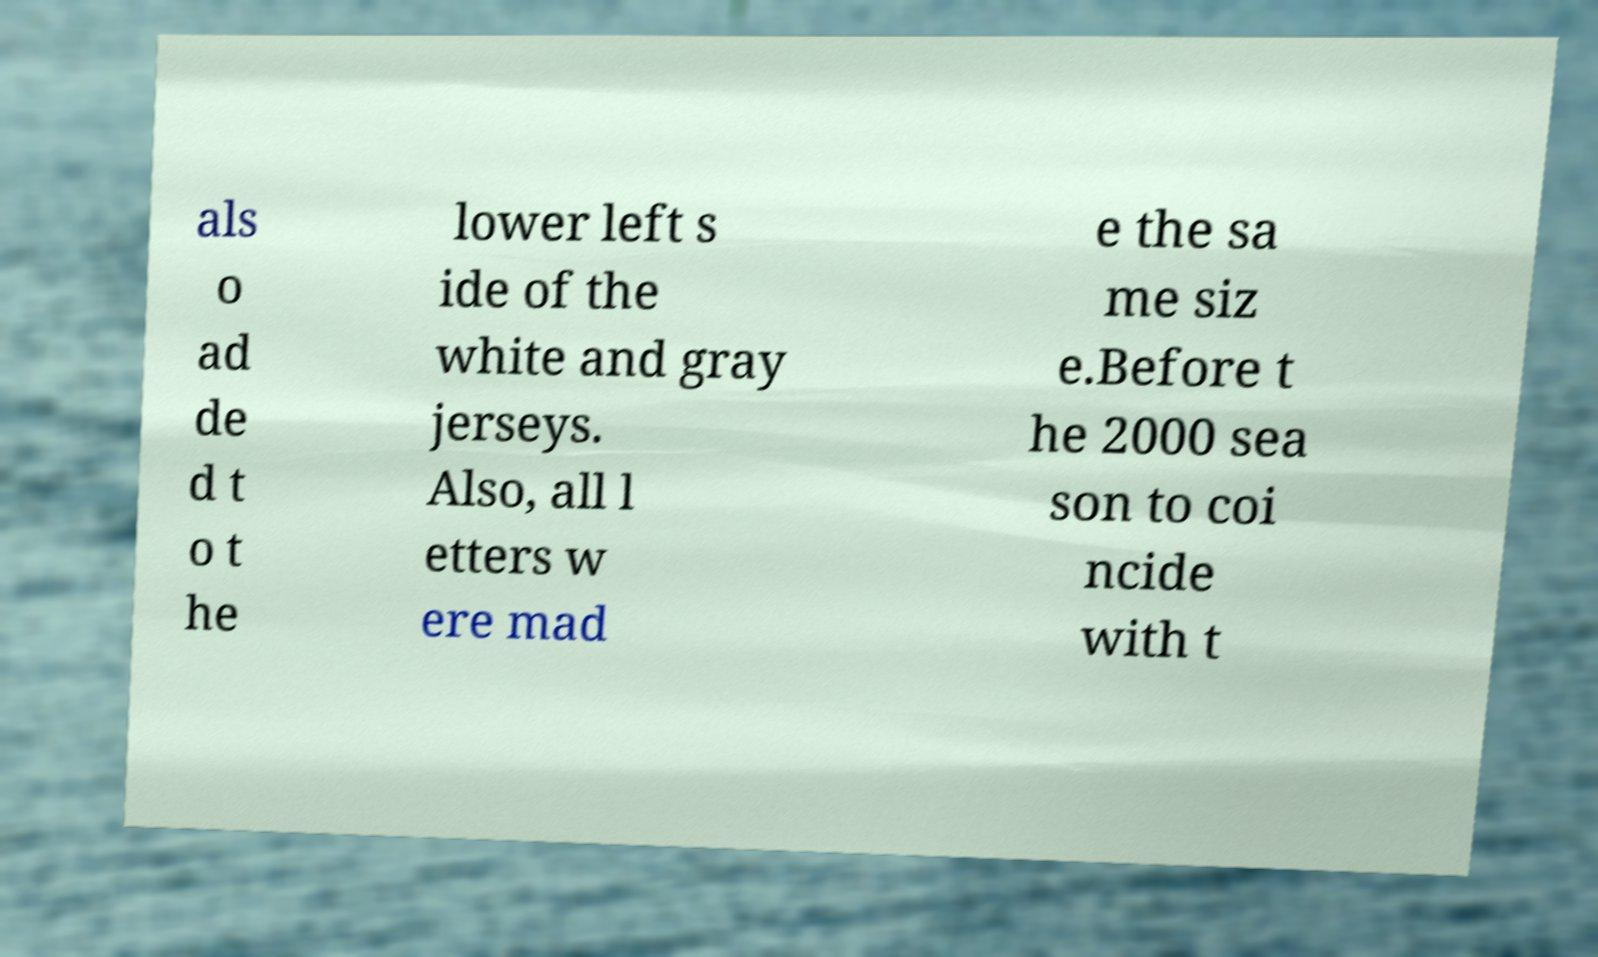Could you extract and type out the text from this image? als o ad de d t o t he lower left s ide of the white and gray jerseys. Also, all l etters w ere mad e the sa me siz e.Before t he 2000 sea son to coi ncide with t 